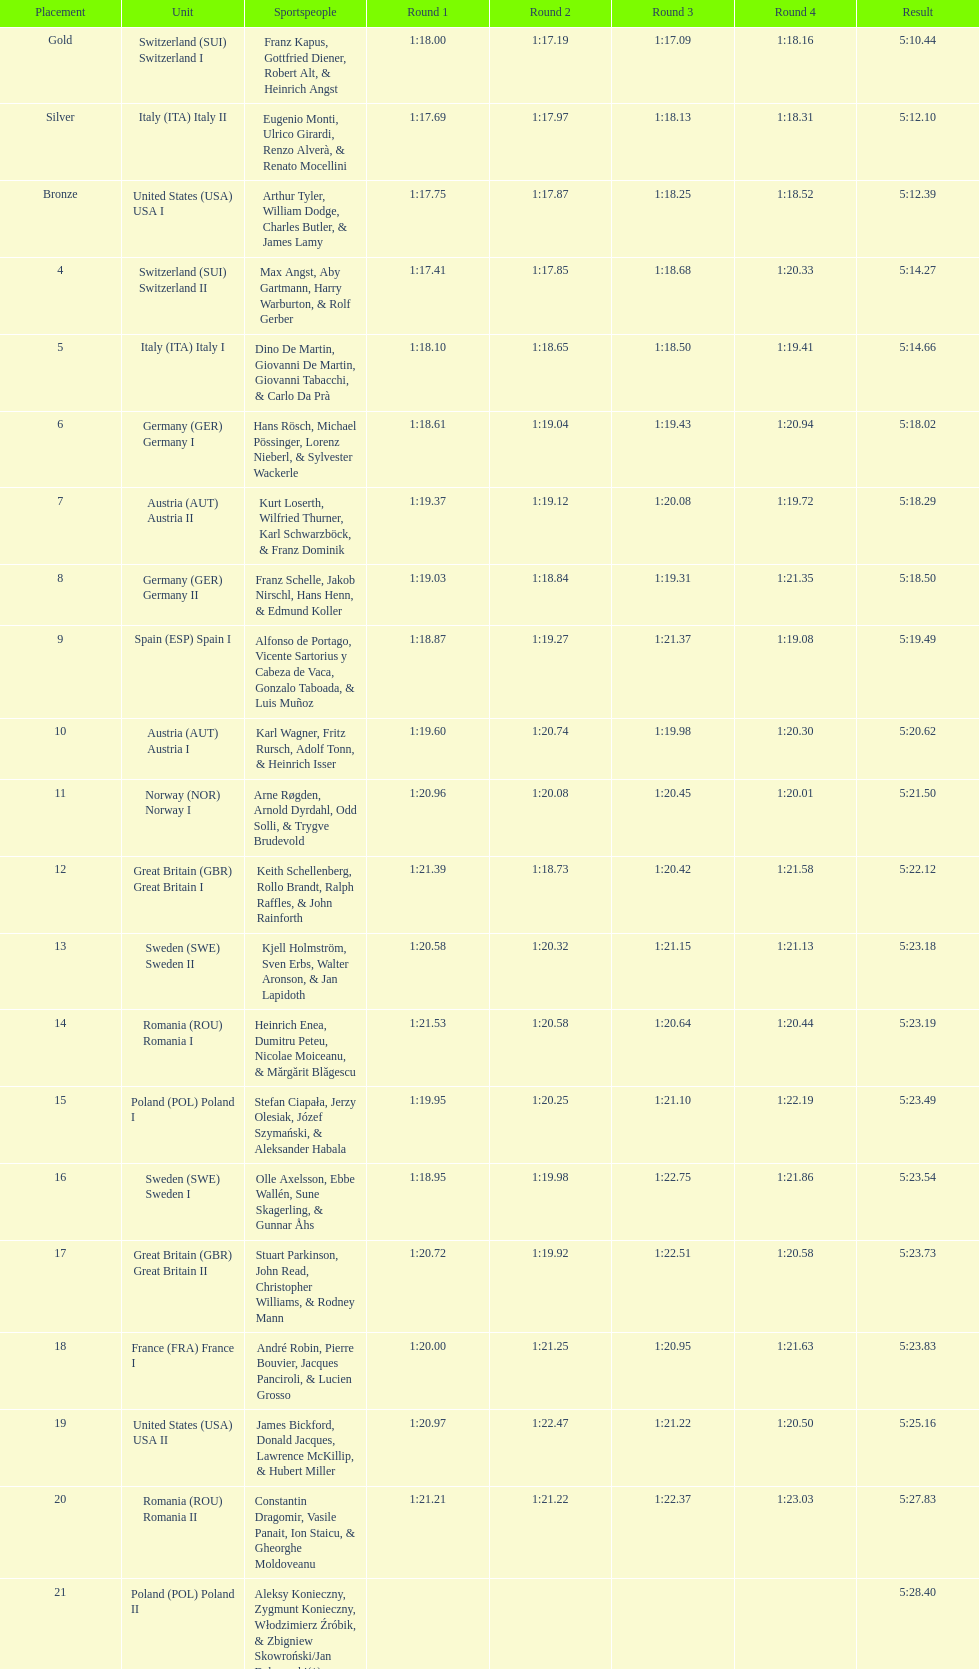What is the total amount of runs? 4. 